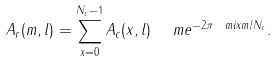Convert formula to latex. <formula><loc_0><loc_0><loc_500><loc_500>A _ { r } ( m , l ) = \sum _ { x = 0 } ^ { N _ { c } - 1 } A _ { c } ( x , l ) \ \ m e ^ { - 2 \pi \ m i x m / N _ { c } } .</formula> 